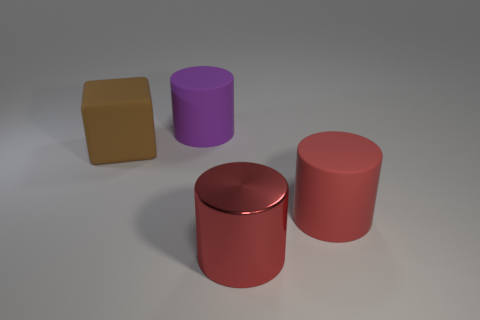Are there fewer red cylinders than small yellow metal cylinders?
Your answer should be compact. No. There is a big thing on the left side of the purple rubber cylinder to the right of the large brown object; what shape is it?
Your response must be concise. Cube. There is a large metallic thing; are there any big things to the left of it?
Provide a succinct answer. Yes. What is the color of the block that is the same size as the red rubber thing?
Offer a terse response. Brown. How many other cylinders have the same material as the purple cylinder?
Offer a terse response. 1. What number of other things are there of the same size as the block?
Your answer should be very brief. 3. Are there any purple rubber things that have the same size as the red rubber object?
Your answer should be very brief. Yes. Does the matte cylinder that is behind the brown cube have the same color as the big rubber block?
Offer a very short reply. No. How many objects are tiny green matte blocks or brown rubber objects?
Provide a short and direct response. 1. There is a matte object that is on the right side of the purple thing; does it have the same size as the brown rubber cube?
Ensure brevity in your answer.  Yes. 